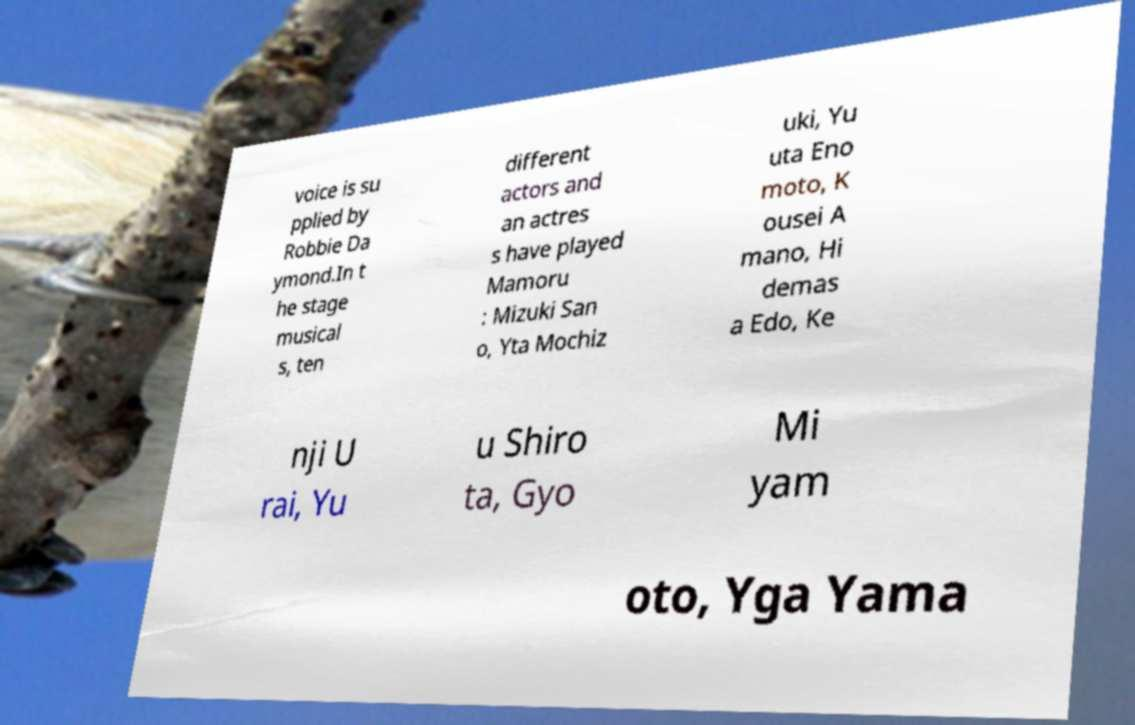Could you extract and type out the text from this image? voice is su pplied by Robbie Da ymond.In t he stage musical s, ten different actors and an actres s have played Mamoru : Mizuki San o, Yta Mochiz uki, Yu uta Eno moto, K ousei A mano, Hi demas a Edo, Ke nji U rai, Yu u Shiro ta, Gyo Mi yam oto, Yga Yama 